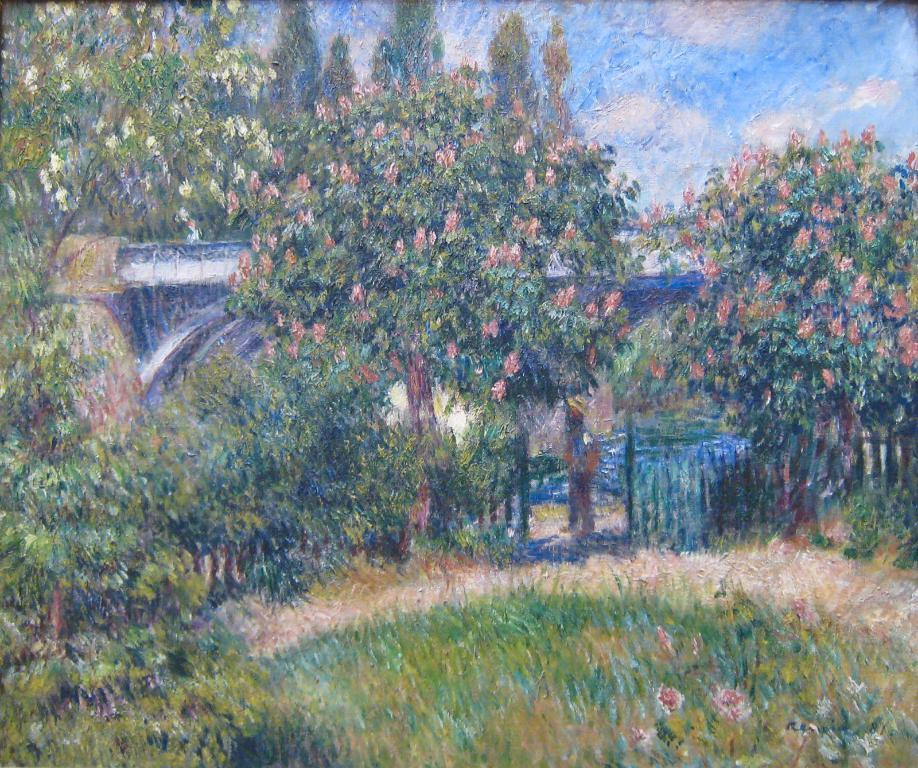What type of natural environment is depicted in the painting? The painting depicts grass, trees, and flowers, which are all elements of a natural environment. What type of man-made structure is depicted in the painting? The painting depicts a fence, which is a man-made structure. What is visible in the sky in the painting? The sky with clouds is visible in the painting. What type of poison can be seen dripping from the flowers in the painting? There is no poison present in the painting; it depicts flowers without any indication of poison. What type of produce is growing on the trees in the painting? There is no produce visible on the trees in the painting; it depicts trees without any fruit or vegetables. 